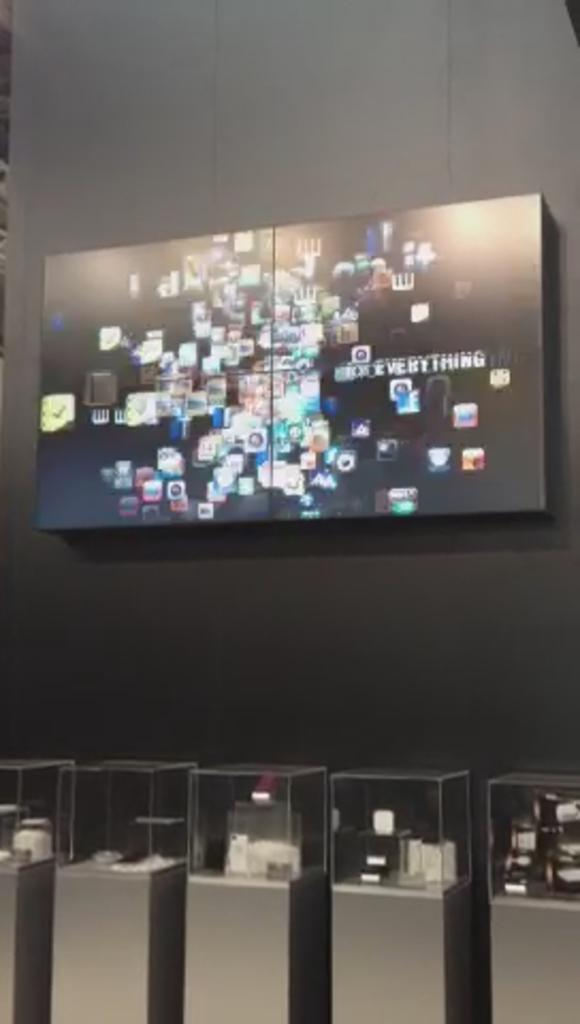Provide a one-sentence caption for the provided image. A large box on the wall with several pictures and the phrase "everything" written on it. 